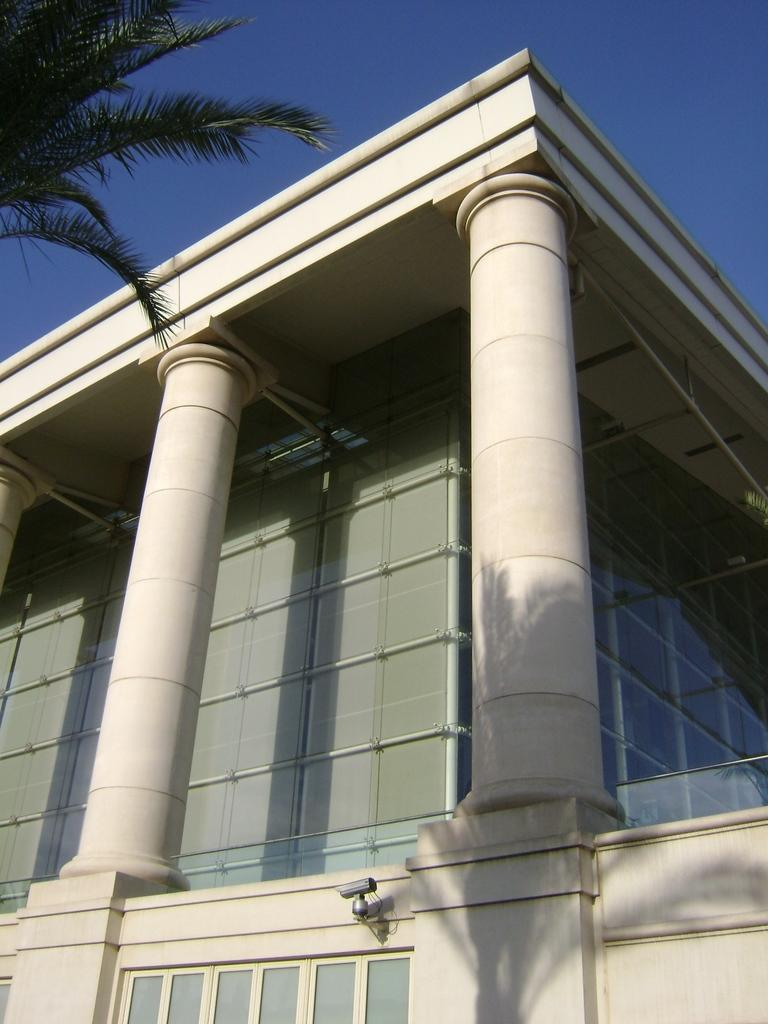What type of structure is present in the image? There is a building in the image. What can be seen on the left side of the image? There is a tree on the left side of the image. What is visible in the background of the image? The sky is visible in the background of the image. What type of shirt is the tree wearing in the image? Trees do not wear shirts, so this question is not applicable to the image. 